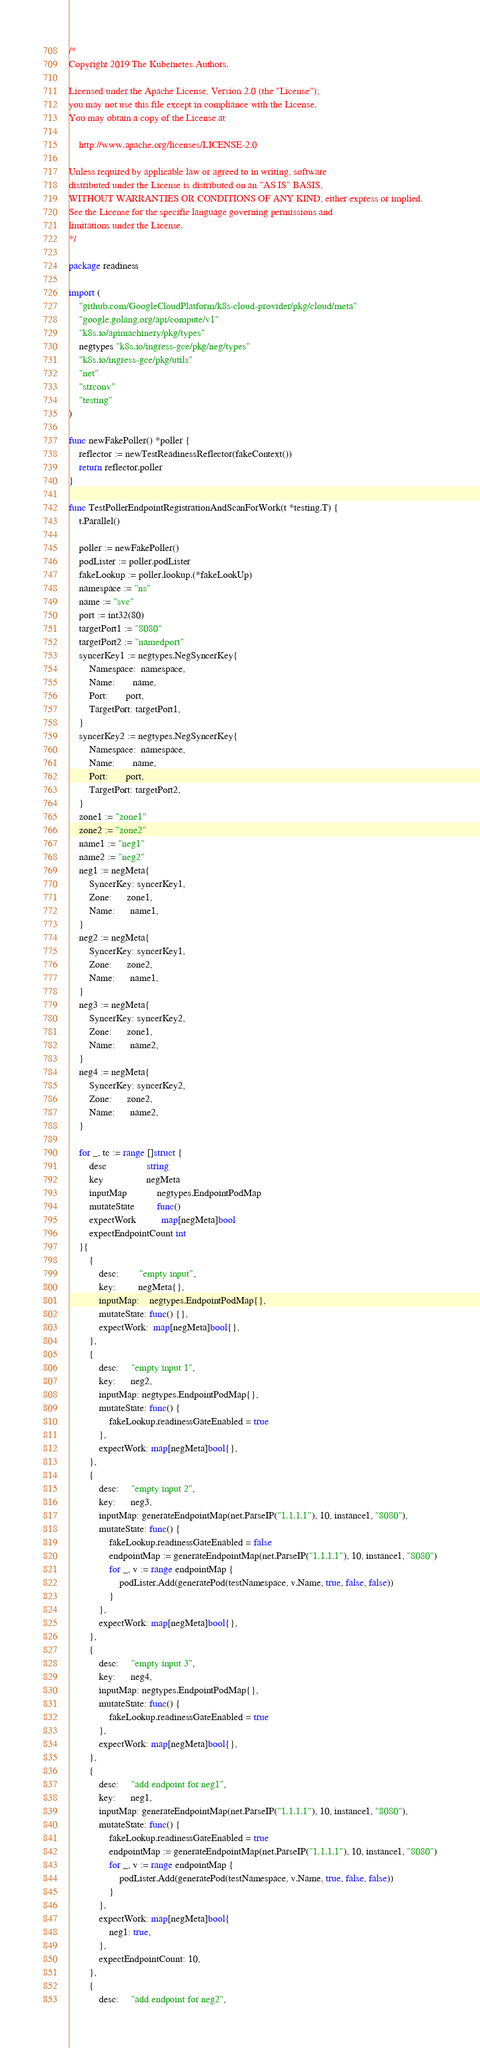Convert code to text. <code><loc_0><loc_0><loc_500><loc_500><_Go_>/*
Copyright 2019 The Kubernetes Authors.

Licensed under the Apache License, Version 2.0 (the "License");
you may not use this file except in compliance with the License.
You may obtain a copy of the License at

    http://www.apache.org/licenses/LICENSE-2.0

Unless required by applicable law or agreed to in writing, software
distributed under the License is distributed on an "AS IS" BASIS,
WITHOUT WARRANTIES OR CONDITIONS OF ANY KIND, either express or implied.
See the License for the specific language governing permissions and
limitations under the License.
*/

package readiness

import (
	"github.com/GoogleCloudPlatform/k8s-cloud-provider/pkg/cloud/meta"
	"google.golang.org/api/compute/v1"
	"k8s.io/apimachinery/pkg/types"
	negtypes "k8s.io/ingress-gce/pkg/neg/types"
	"k8s.io/ingress-gce/pkg/utils"
	"net"
	"strconv"
	"testing"
)

func newFakePoller() *poller {
	reflector := newTestReadinessReflector(fakeContext())
	return reflector.poller
}

func TestPollerEndpointRegistrationAndScanForWork(t *testing.T) {
	t.Parallel()

	poller := newFakePoller()
	podLister := poller.podLister
	fakeLookup := poller.lookup.(*fakeLookUp)
	namespace := "ns"
	name := "svc"
	port := int32(80)
	targetPort1 := "8080"
	targetPort2 := "namedport"
	syncerKey1 := negtypes.NegSyncerKey{
		Namespace:  namespace,
		Name:       name,
		Port:       port,
		TargetPort: targetPort1,
	}
	syncerKey2 := negtypes.NegSyncerKey{
		Namespace:  namespace,
		Name:       name,
		Port:       port,
		TargetPort: targetPort2,
	}
	zone1 := "zone1"
	zone2 := "zone2"
	name1 := "neg1"
	name2 := "neg2"
	neg1 := negMeta{
		SyncerKey: syncerKey1,
		Zone:      zone1,
		Name:      name1,
	}
	neg2 := negMeta{
		SyncerKey: syncerKey1,
		Zone:      zone2,
		Name:      name1,
	}
	neg3 := negMeta{
		SyncerKey: syncerKey2,
		Zone:      zone1,
		Name:      name2,
	}
	neg4 := negMeta{
		SyncerKey: syncerKey2,
		Zone:      zone2,
		Name:      name2,
	}

	for _, tc := range []struct {
		desc                string
		key                 negMeta
		inputMap            negtypes.EndpointPodMap
		mutateState         func()
		expectWork          map[negMeta]bool
		expectEndpointCount int
	}{
		{
			desc:        "empty input",
			key:         negMeta{},
			inputMap:    negtypes.EndpointPodMap{},
			mutateState: func() {},
			expectWork:  map[negMeta]bool{},
		},
		{
			desc:     "empty input 1",
			key:      neg2,
			inputMap: negtypes.EndpointPodMap{},
			mutateState: func() {
				fakeLookup.readinessGateEnabled = true
			},
			expectWork: map[negMeta]bool{},
		},
		{
			desc:     "empty input 2",
			key:      neg3,
			inputMap: generateEndpointMap(net.ParseIP("1.1.1.1"), 10, instance1, "8080"),
			mutateState: func() {
				fakeLookup.readinessGateEnabled = false
				endpointMap := generateEndpointMap(net.ParseIP("1.1.1.1"), 10, instance1, "8080")
				for _, v := range endpointMap {
					podLister.Add(generatePod(testNamespace, v.Name, true, false, false))
				}
			},
			expectWork: map[negMeta]bool{},
		},
		{
			desc:     "empty input 3",
			key:      neg4,
			inputMap: negtypes.EndpointPodMap{},
			mutateState: func() {
				fakeLookup.readinessGateEnabled = true
			},
			expectWork: map[negMeta]bool{},
		},
		{
			desc:     "add endpoint for neg1",
			key:      neg1,
			inputMap: generateEndpointMap(net.ParseIP("1.1.1.1"), 10, instance1, "8080"),
			mutateState: func() {
				fakeLookup.readinessGateEnabled = true
				endpointMap := generateEndpointMap(net.ParseIP("1.1.1.1"), 10, instance1, "8080")
				for _, v := range endpointMap {
					podLister.Add(generatePod(testNamespace, v.Name, true, false, false))
				}
			},
			expectWork: map[negMeta]bool{
				neg1: true,
			},
			expectEndpointCount: 10,
		},
		{
			desc:     "add endpoint for neg2",</code> 